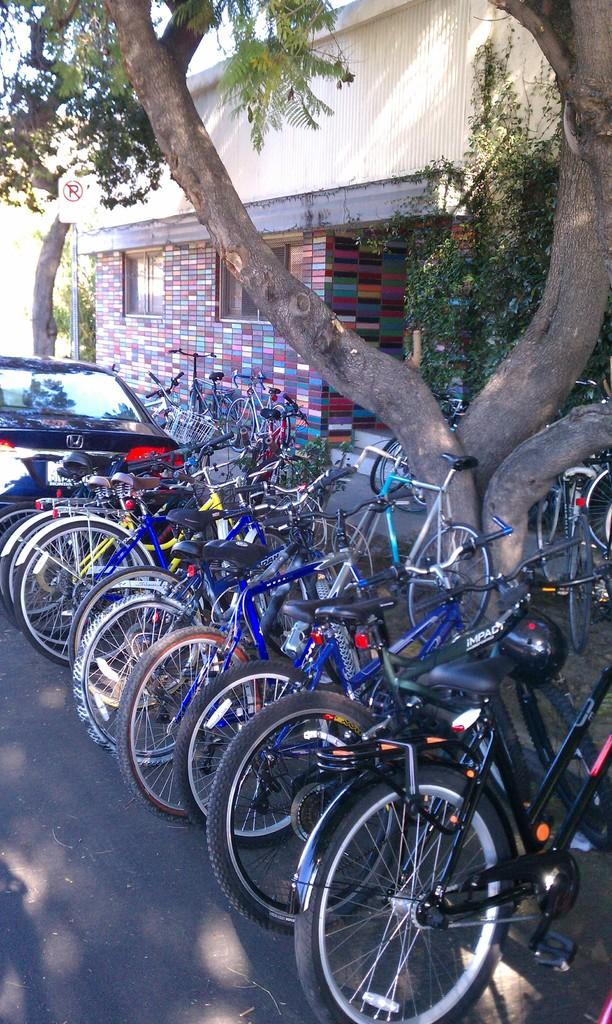What type of vehicles are present in the image? There are bicycles in the image. What other mode of transportation can be seen in the image? There is a car parked in the image. What type of natural elements are visible in the image? There are trees in the image. What type of structure is visible in the background of the image? There is a house in the background of the image. What type of cough medicine is visible on the bicycle in the image? There is no cough medicine visible in the image; it features bicycles, a car, trees, and a house in the background. 